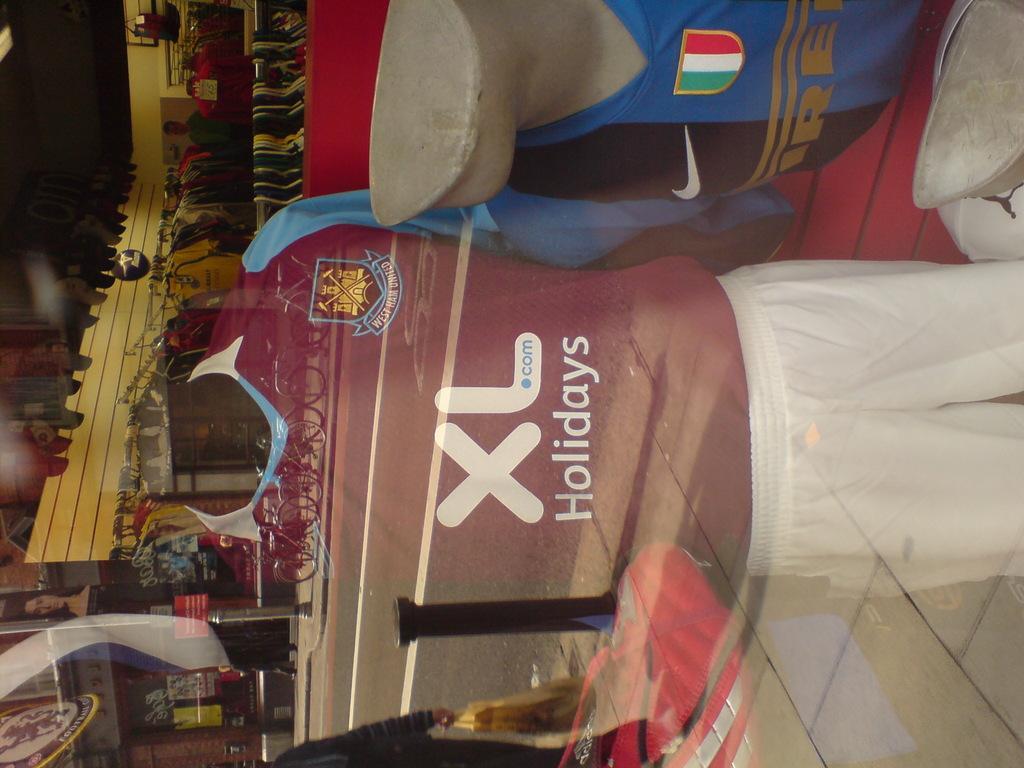In one or two sentences, can you explain what this image depicts? In this picture we can see two mannequins with dresses and on the glass we can see the reflection of the road, bicycles, here we can see some objects. 